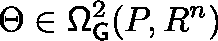<formula> <loc_0><loc_0><loc_500><loc_500>\Theta \in \Omega _ { G } ^ { 2 } ( P , \mathbb { R } ^ { n } )</formula> 